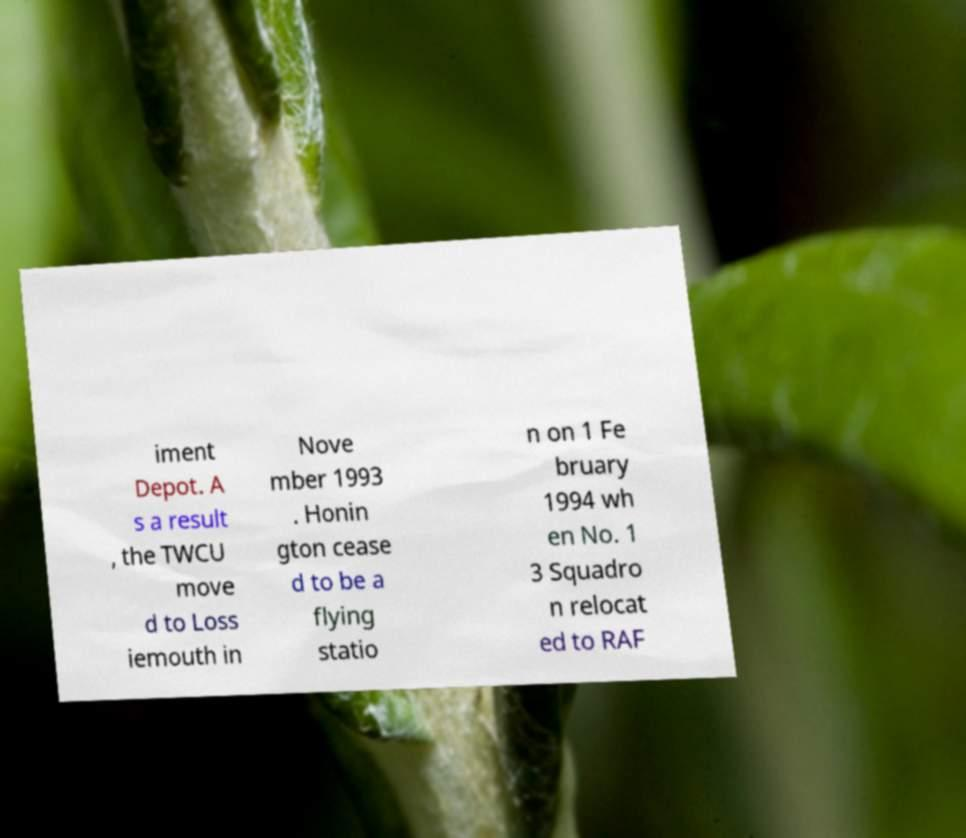Could you assist in decoding the text presented in this image and type it out clearly? iment Depot. A s a result , the TWCU move d to Loss iemouth in Nove mber 1993 . Honin gton cease d to be a flying statio n on 1 Fe bruary 1994 wh en No. 1 3 Squadro n relocat ed to RAF 